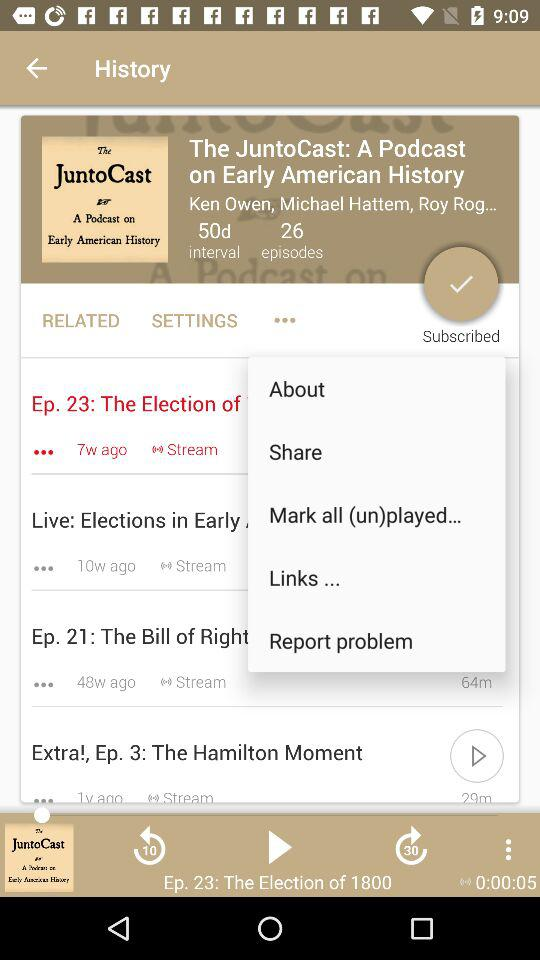What is the total time interval of "The JuntoCast"? The total time interval of "The JuntoCast" is 50 days. 